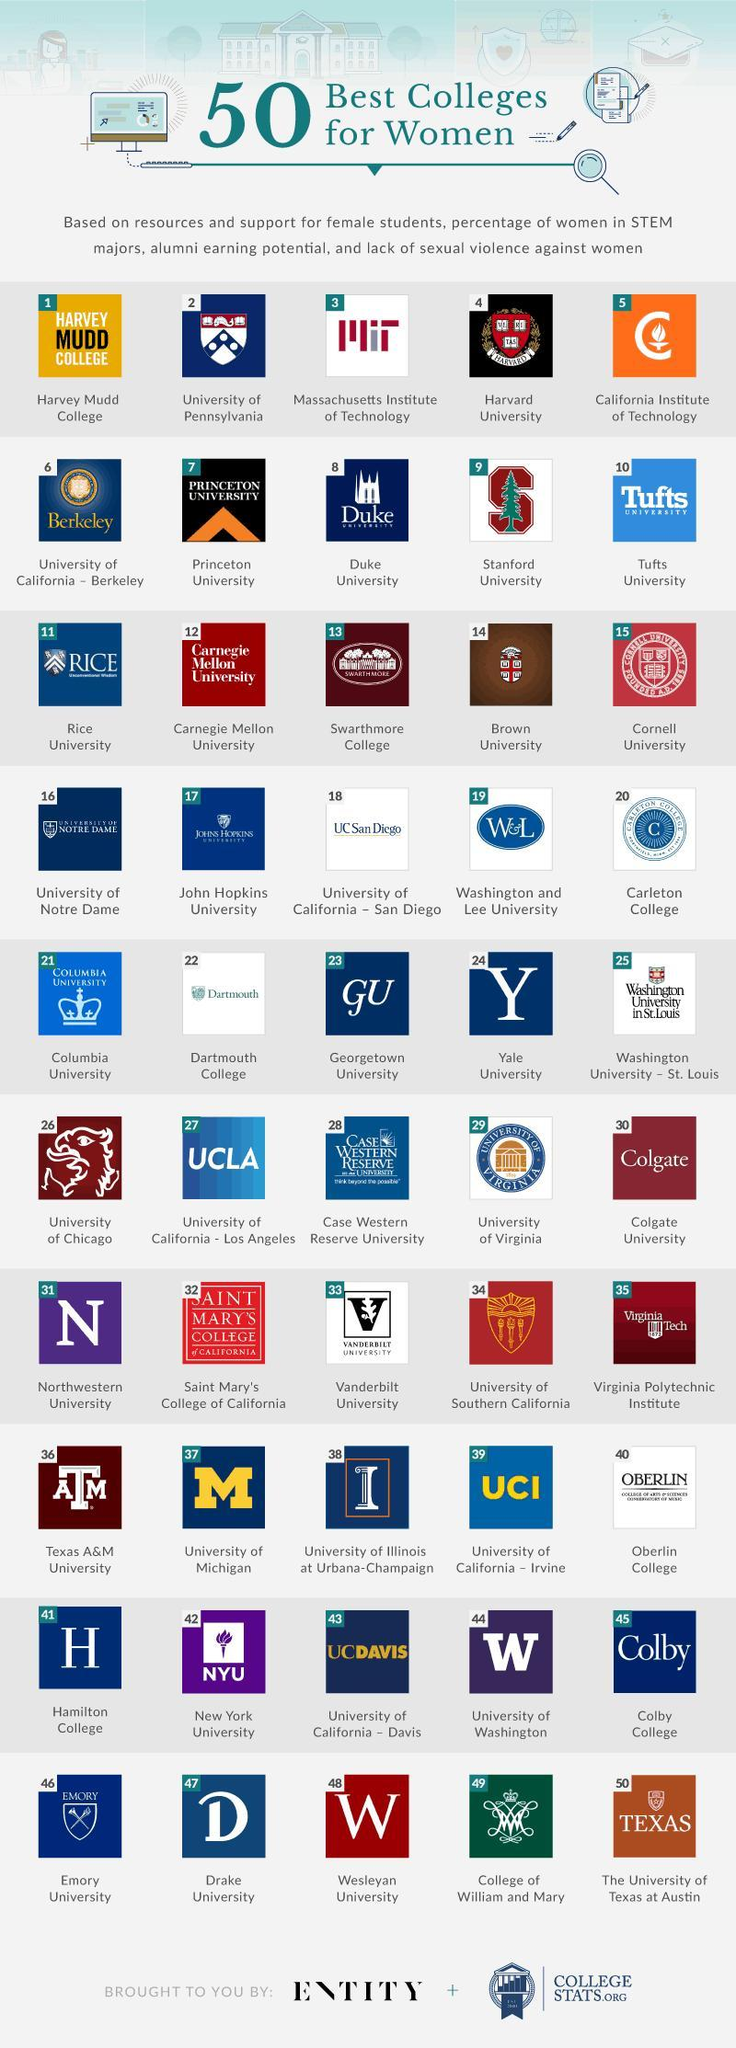What is the background colour for the logo of Tufts university - blue, green or red?
Answer the question with a short phrase. blue Which is the fourth best college for women? harvard university 